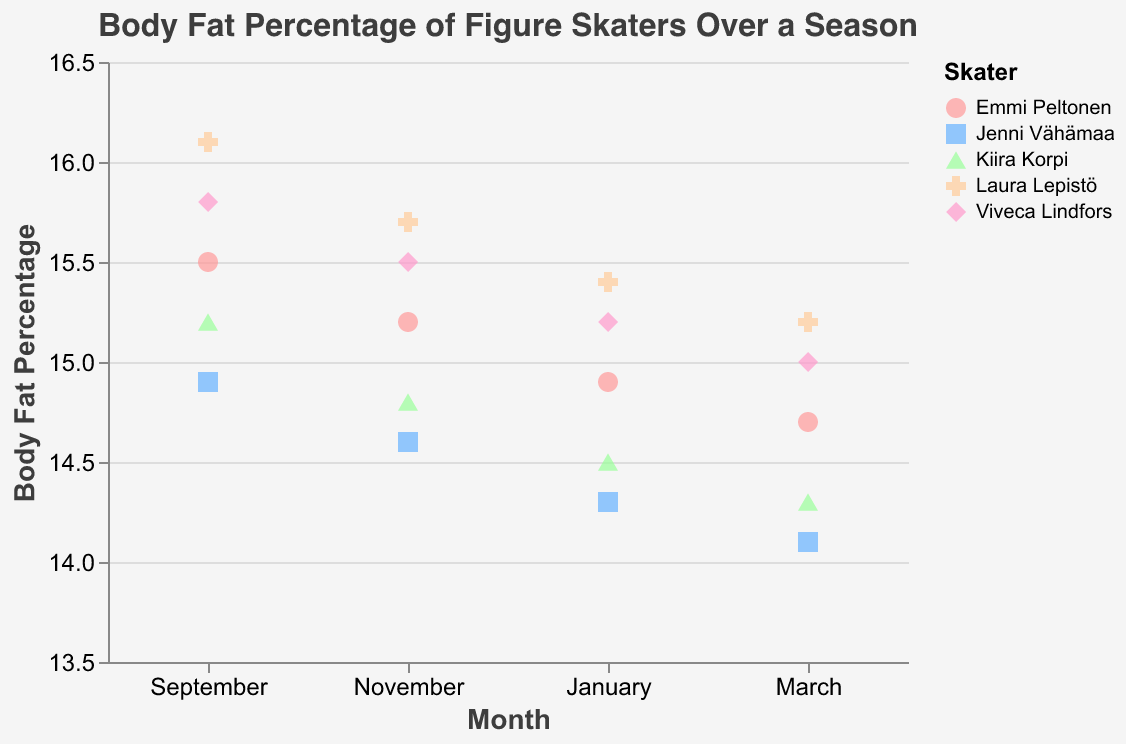How many figure skaters are represented in the data? There are five skaters: Kiira Korpi, Laura Lepistö, Jenni Vähämaa, Viveca Lindfors, and Emmi Peltonen.
Answer: 5 What's the overall trend in body fat percentage from September to March for all skaters? All skaters show a general decrease in body fat percentage from September to March.
Answer: Decrease Which skater had the highest body fat percentage in September? By looking at the values for September, Laura Lepistö had the highest body fat percentage at 16.1%.
Answer: Laura Lepistö Which month had the highest body fat percentage for Kiira Korpi? Kiira Korpi had the highest body fat percentage in September at 15.2%.
Answer: September For which months did Viveca Lindfors's body fat percentage decrease? From the figure, her body fat percentage decreased from September to November, November to January, and January to March.
Answer: All months What's the difference in body fat percentage between Kiira Korpi and Laura Lepistö in January? Kiira Korpi has 14.5% and Laura Lepistö has 15.4% in January. Their difference is 15.4 - 14.5 = 0.9%.
Answer: 0.9% Who had the lowest body fat percentage in March? The lowest body fat percentage in March was by Jenni Vähämaa at 14.1%.
Answer: Jenni Vähämaa How does Emmi Peltonen's body fat percentage change from November to January? Emmi Peltonen's body fat percentage decreased from 15.2% in November to 14.9% in January, a reduction of 0.3%.
Answer: Decreased Which skater showed the greatest decrease in body fat percentage from September to March? Calculating the decrease for each skater: Kiira Korpi (15.2 to 14.3 = 0.9%), Laura Lepistö (16.1 to 15.2 = 0.9%), Jenni Vähämaa (14.9 to 14.1 = 0.8%), Viveca Lindfors (15.8 to 15.0 = 0.8%), Emmi Peltonen (15.5 to 14.7 = 0.8%). So, it's a tie between Kiira Korpi and Laura Lepistö with 0.9%.
Answer: Kiira Korpi and Laura Lepistö What's the average body fat percentage for all skaters in March? Summing the values for March: 14.3 (Kiira Korpi) + 15.2 (Laura Lepistö) + 14.1 (Jenni Vähämaa) + 15.0 (Viveca Lindfors) + 14.7 (Emmi Peltonen) = 73.3. Divided by 5 skaters, the average is 73.3 / 5 = 14.66%.
Answer: 14.66% 